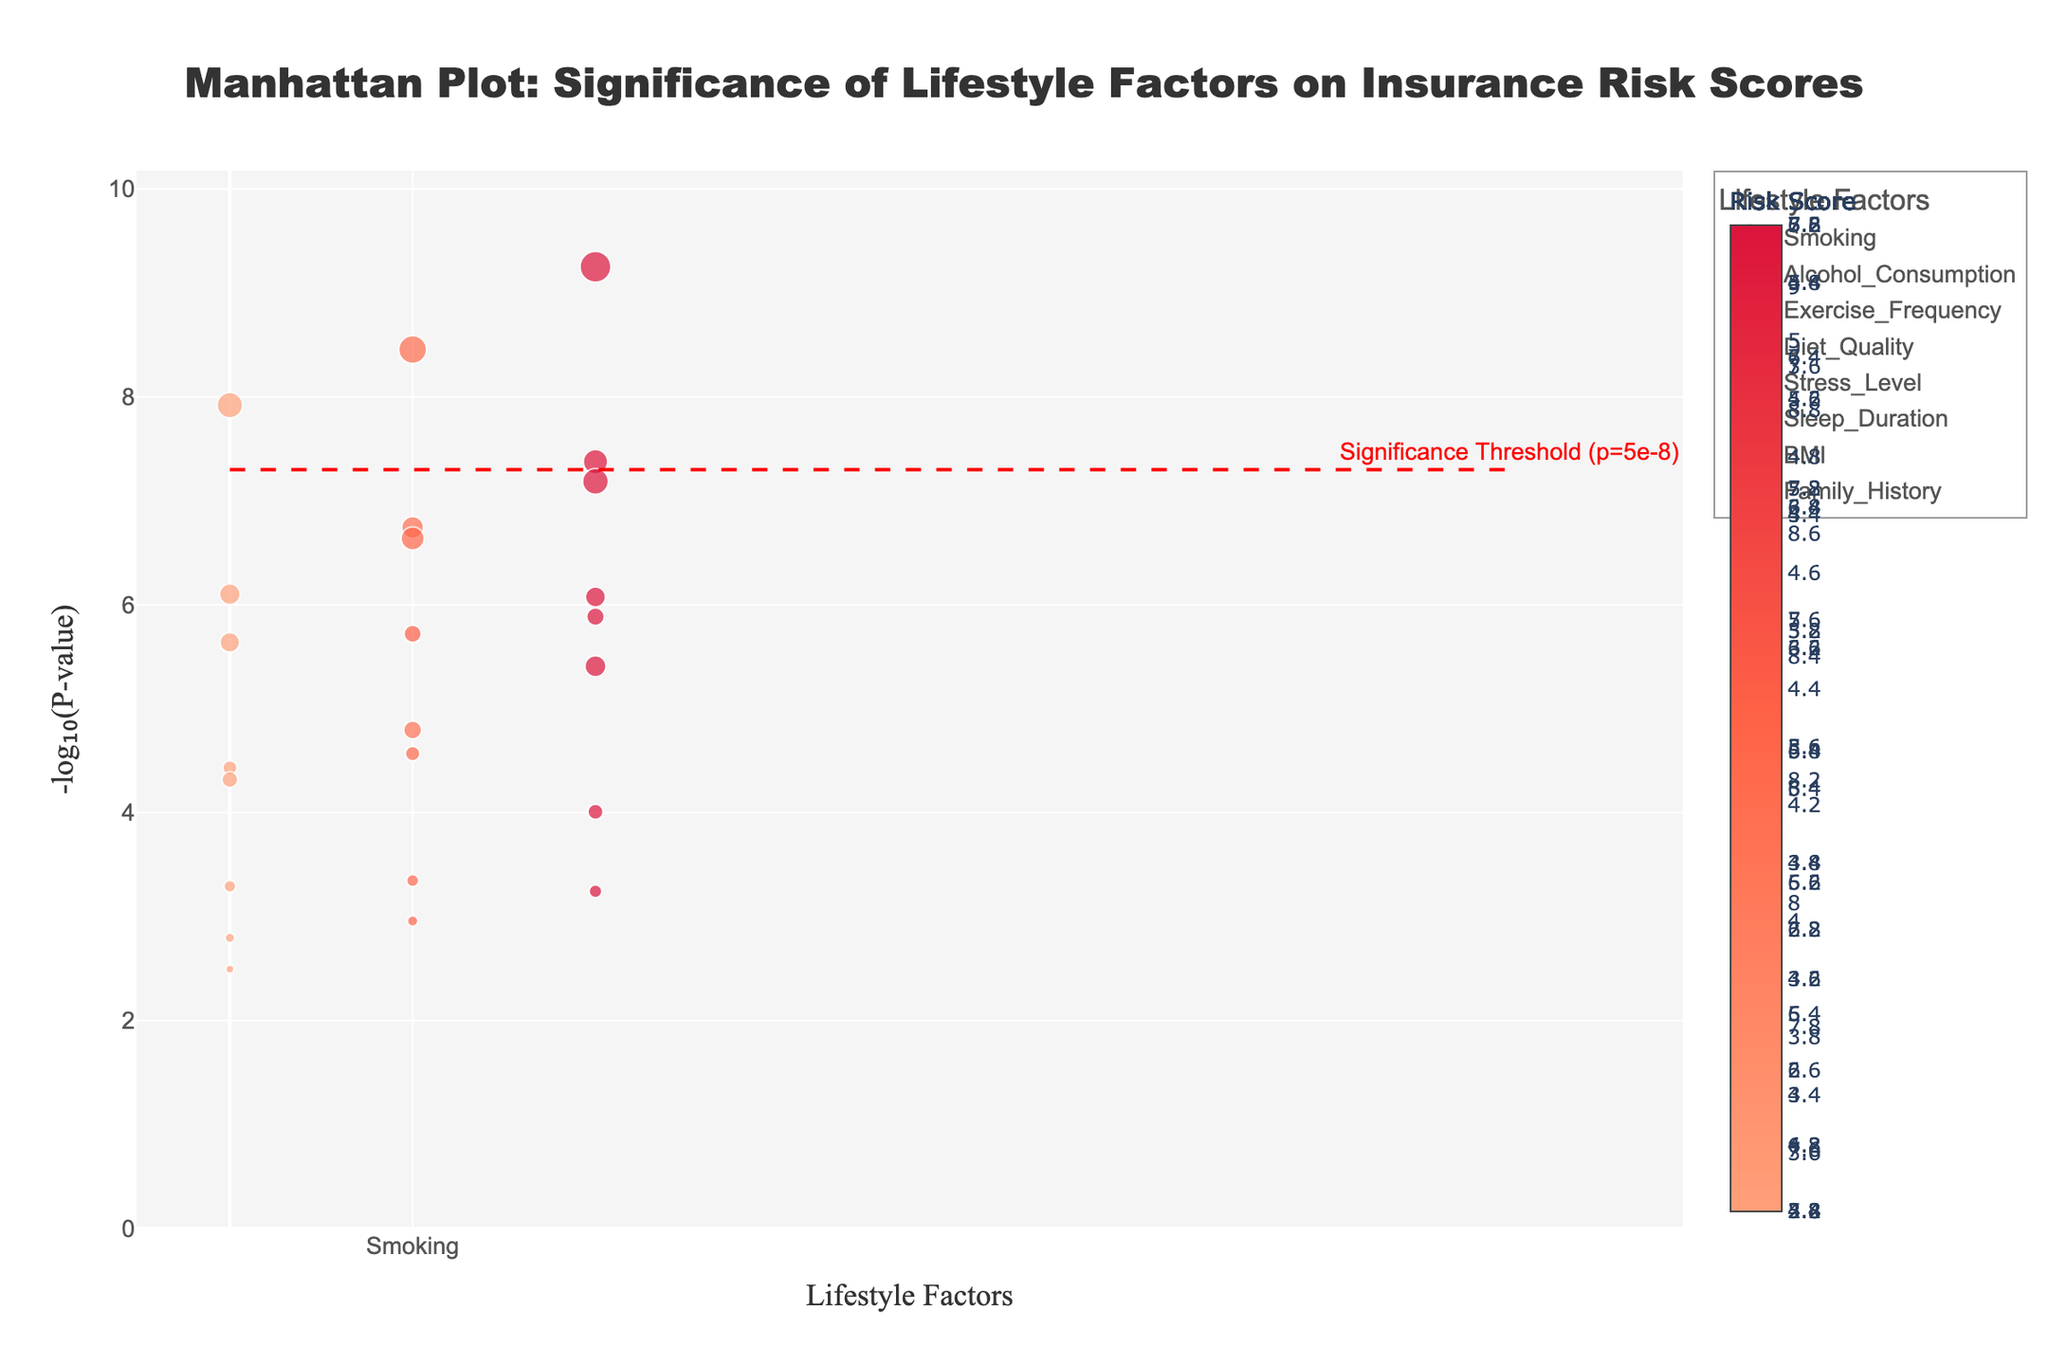What is the title of the Manhattan Plot? The title can be found at the top of the plot. It reads 'Manhattan Plot: Significance of Lifestyle Factors on Insurance Risk Scores'.
Answer: Manhattan Plot: Significance of Lifestyle Factors on Insurance Risk Scores Which lifestyle factor has the smallest p-value for the age group 51-70? To find this, locate the points representing the age group 51-70 and compare their heights. Smoking has the tallest point (largest -log₁₀(p-value)), indicating the smallest p-value.
Answer: Smoking What is the risk score associated with the highest significance value for Exercise Frequency in the age group 31-50? Identify the point for Exercise Frequency in the age group 31-50 with the highest -log₁₀(p-value). This point has a risk score of 5.1, as indicated in the plot.
Answer: 5.1 How does the significance of Smoking differ between the age groups 18-30 and 51-70? Compare the heights of the points representing Smoking for these age groups. The Smoking point for 51-70 is significantly higher than that for 18-30, meaning a much smaller p-value (higher significance).
Answer: Significantly higher for 51-70 Which lifestyle factor has the lowest risk score for the age group 18-30 and what is it? Look at the points representing the age group 18-30 and find the smallest circle. The smallest circle is Sleep Duration with a risk score of 2.4.
Answer: Sleep Duration, 2.4 Are there any age groups where Diet Quality has a higher significance than Stress Level? If yes, which ones? Compare points for Diet Quality and Stress Level across all age groups by checking their heights. In all age groups (18-30, 31-50, 51-70), Diet Quality has taller points than Stress Level, indicating higher significance (smaller p-values).
Answer: Yes, all age groups What is the significance threshold for this plot? The plot includes a horizontal dashed red line with an annotation indicating the threshold, which is at p=5e-8.
Answer: p=5e-8 Which age group shows the highest risk score for Family History? Check the points for Family History and compare their sizes (proportional to risk scores). The largest circle corresponds to the age group 51-70 with a risk score of 6.2.
Answer: 51-70 